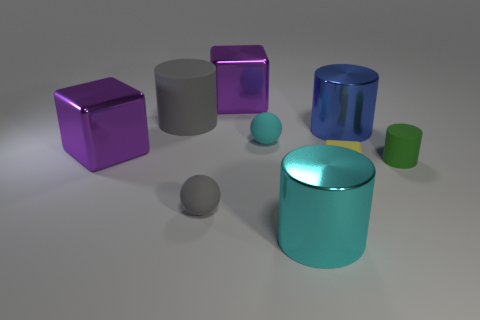How many cyan things are either matte spheres or small things?
Give a very brief answer. 1. How many other tiny objects are the same shape as the tiny gray matte object?
Ensure brevity in your answer.  1. What number of purple things are the same size as the yellow rubber thing?
Your response must be concise. 0. There is another object that is the same shape as the cyan rubber thing; what material is it?
Give a very brief answer. Rubber. There is a rubber object that is behind the cyan matte ball; what color is it?
Your answer should be compact. Gray. Is the number of small gray rubber things right of the big blue shiny cylinder greater than the number of small yellow blocks?
Offer a terse response. No. What color is the tiny rubber block?
Provide a succinct answer. Yellow. The small green matte thing that is in front of the large purple thing right of the matte cylinder to the left of the green cylinder is what shape?
Provide a short and direct response. Cylinder. There is a big cylinder that is both right of the cyan matte object and left of the large blue thing; what is it made of?
Ensure brevity in your answer.  Metal. What is the shape of the metal object on the right side of the shiny cylinder in front of the large blue metallic thing?
Keep it short and to the point. Cylinder. 